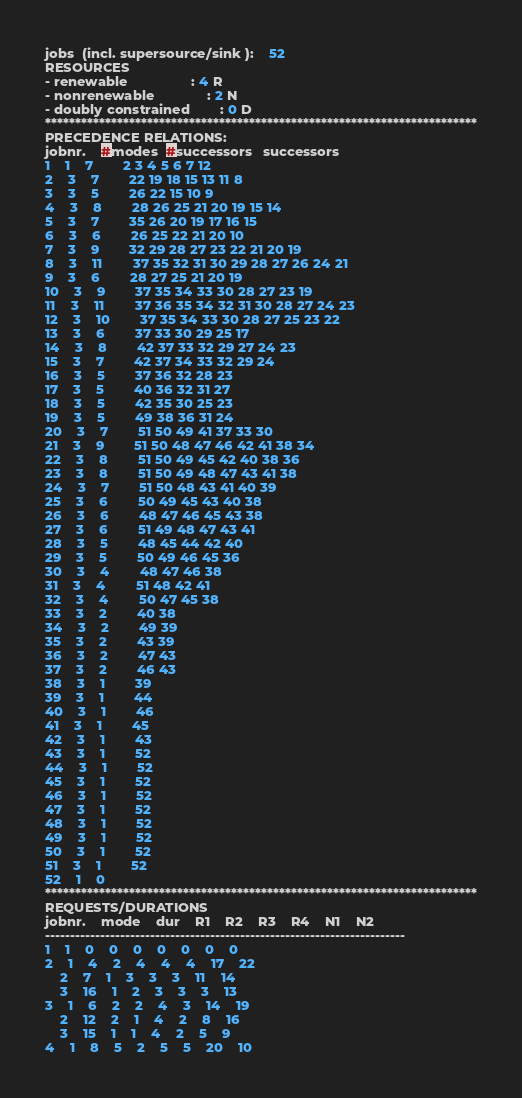Convert code to text. <code><loc_0><loc_0><loc_500><loc_500><_ObjectiveC_>jobs  (incl. supersource/sink ):	52
RESOURCES
- renewable                 : 4 R
- nonrenewable              : 2 N
- doubly constrained        : 0 D
************************************************************************
PRECEDENCE RELATIONS:
jobnr.    #modes  #successors   successors
1	1	7		2 3 4 5 6 7 12 
2	3	7		22 19 18 15 13 11 8 
3	3	5		26 22 15 10 9 
4	3	8		28 26 25 21 20 19 15 14 
5	3	7		35 26 20 19 17 16 15 
6	3	6		26 25 22 21 20 10 
7	3	9		32 29 28 27 23 22 21 20 19 
8	3	11		37 35 32 31 30 29 28 27 26 24 21 
9	3	6		28 27 25 21 20 19 
10	3	9		37 35 34 33 30 28 27 23 19 
11	3	11		37 36 35 34 32 31 30 28 27 24 23 
12	3	10		37 35 34 33 30 28 27 25 23 22 
13	3	6		37 33 30 29 25 17 
14	3	8		42 37 33 32 29 27 24 23 
15	3	7		42 37 34 33 32 29 24 
16	3	5		37 36 32 28 23 
17	3	5		40 36 32 31 27 
18	3	5		42 35 30 25 23 
19	3	5		49 38 36 31 24 
20	3	7		51 50 49 41 37 33 30 
21	3	9		51 50 48 47 46 42 41 38 34 
22	3	8		51 50 49 45 42 40 38 36 
23	3	8		51 50 49 48 47 43 41 38 
24	3	7		51 50 48 43 41 40 39 
25	3	6		50 49 45 43 40 38 
26	3	6		48 47 46 45 43 38 
27	3	6		51 49 48 47 43 41 
28	3	5		48 45 44 42 40 
29	3	5		50 49 46 45 36 
30	3	4		48 47 46 38 
31	3	4		51 48 42 41 
32	3	4		50 47 45 38 
33	3	2		40 38 
34	3	2		49 39 
35	3	2		43 39 
36	3	2		47 43 
37	3	2		46 43 
38	3	1		39 
39	3	1		44 
40	3	1		46 
41	3	1		45 
42	3	1		43 
43	3	1		52 
44	3	1		52 
45	3	1		52 
46	3	1		52 
47	3	1		52 
48	3	1		52 
49	3	1		52 
50	3	1		52 
51	3	1		52 
52	1	0		
************************************************************************
REQUESTS/DURATIONS
jobnr.	mode	dur	R1	R2	R3	R4	N1	N2	
------------------------------------------------------------------------
1	1	0	0	0	0	0	0	0	
2	1	4	2	4	4	4	17	22	
	2	7	1	3	3	3	11	14	
	3	16	1	2	3	3	3	13	
3	1	6	2	2	4	3	14	19	
	2	12	2	1	4	2	8	16	
	3	15	1	1	4	2	5	9	
4	1	8	5	2	5	5	20	10	</code> 